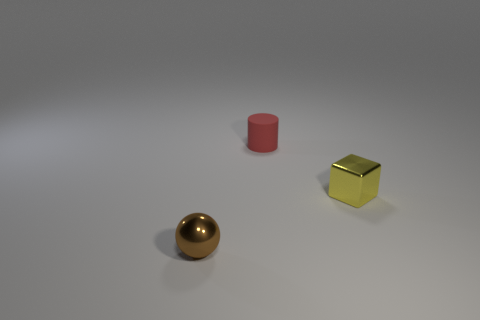Subtract all cyan spheres. Subtract all purple cubes. How many spheres are left? 1 Add 1 small brown things. How many objects exist? 4 Subtract all blocks. How many objects are left? 2 Add 3 yellow metal objects. How many yellow metal objects are left? 4 Add 1 large purple matte cylinders. How many large purple matte cylinders exist? 1 Subtract 0 purple cylinders. How many objects are left? 3 Subtract all tiny yellow things. Subtract all tiny red rubber things. How many objects are left? 1 